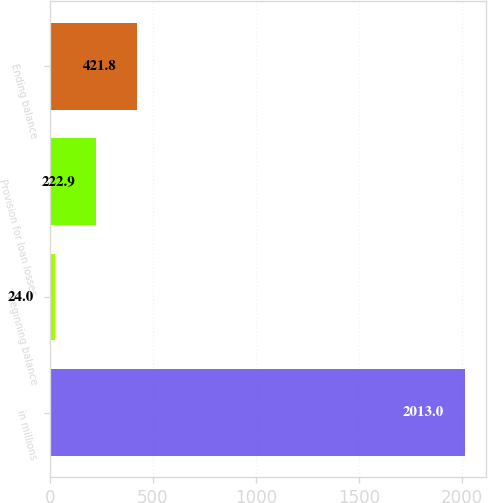Convert chart to OTSL. <chart><loc_0><loc_0><loc_500><loc_500><bar_chart><fcel>in millions<fcel>Beginning balance<fcel>Provision for loan losses<fcel>Ending balance<nl><fcel>2013<fcel>24<fcel>222.9<fcel>421.8<nl></chart> 